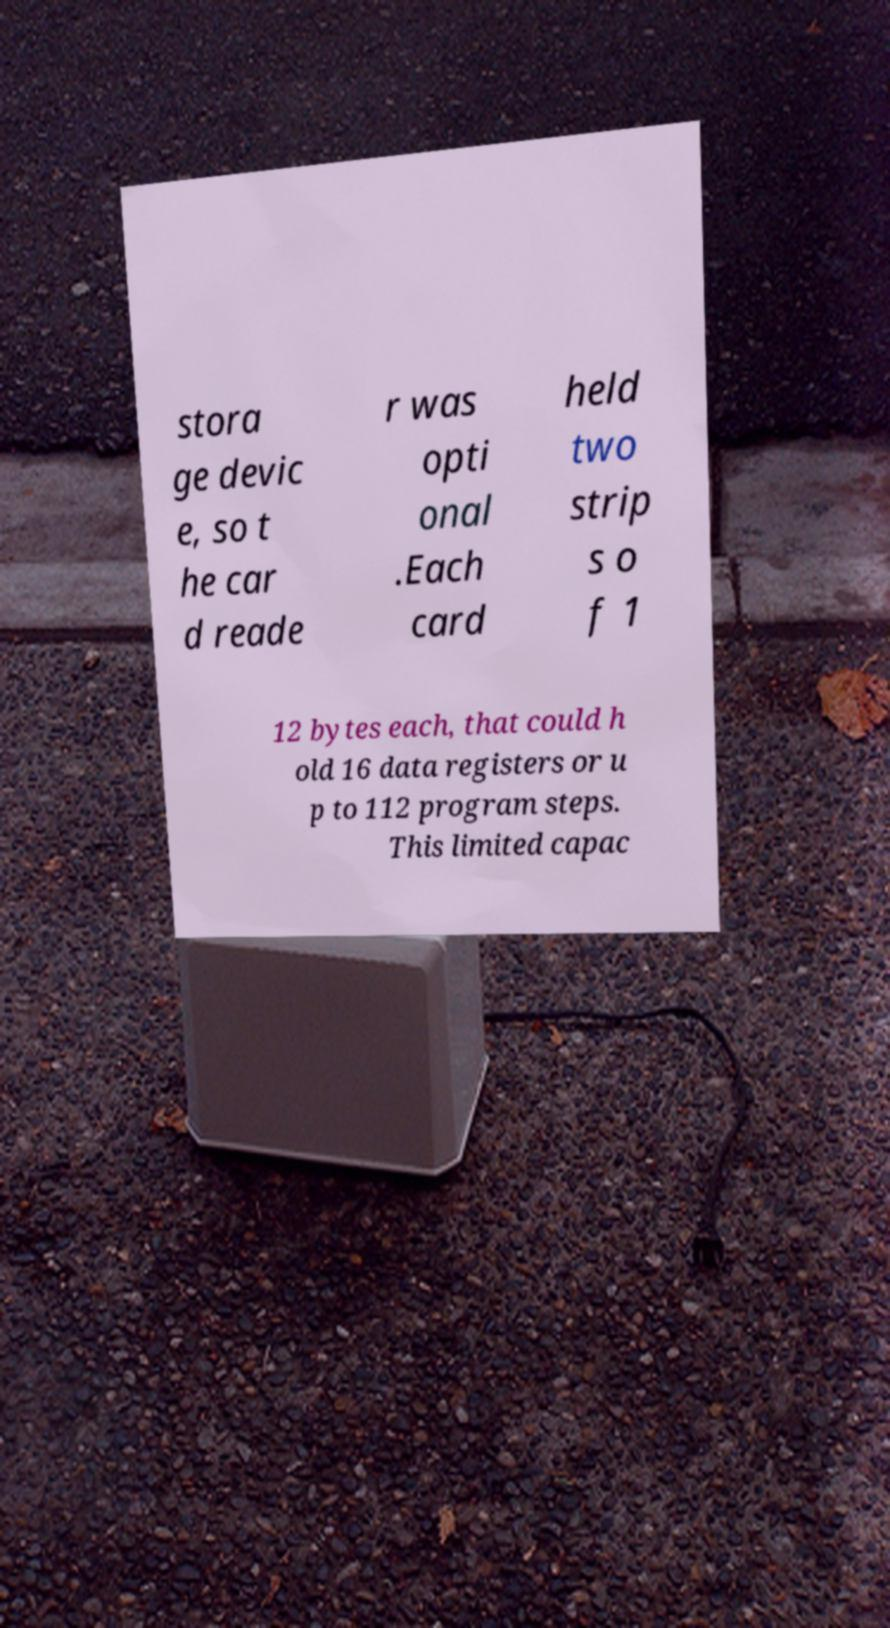Can you read and provide the text displayed in the image?This photo seems to have some interesting text. Can you extract and type it out for me? stora ge devic e, so t he car d reade r was opti onal .Each card held two strip s o f 1 12 bytes each, that could h old 16 data registers or u p to 112 program steps. This limited capac 